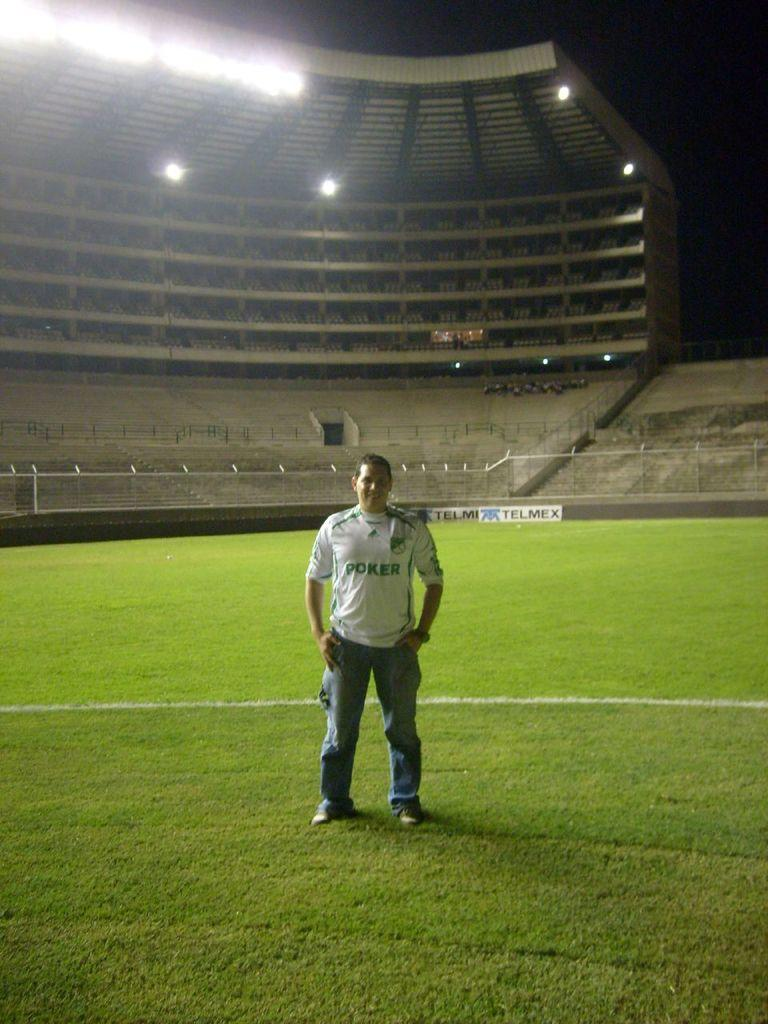<image>
Relay a brief, clear account of the picture shown. A man wearing a white Poker shirt and jeans stands inside a stadium on a sports field. 